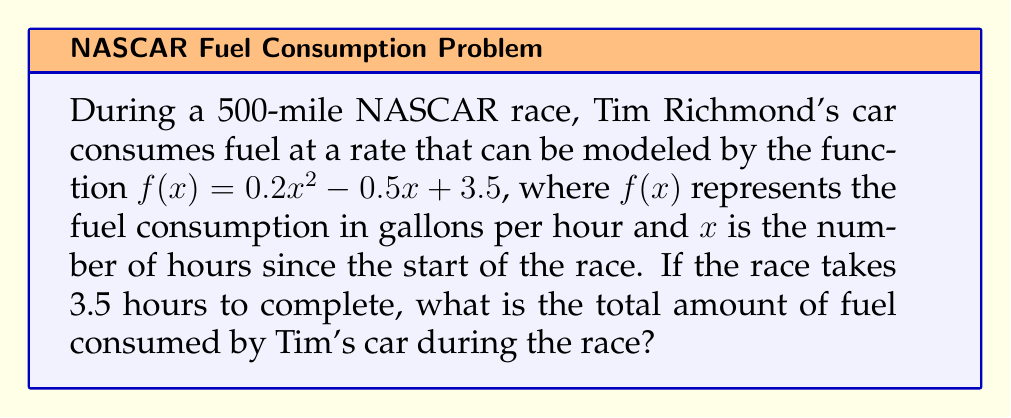Help me with this question. To solve this problem, we need to find the integral of the fuel consumption rate function over the duration of the race. Here's how we do it step-by-step:

1) The fuel consumption rate is given by $f(x) = 0.2x^2 - 0.5x + 3.5$ gallons per hour.

2) To find the total fuel consumed, we need to integrate this function from $x=0$ to $x=3.5$ (the duration of the race):

   $$\int_0^{3.5} (0.2x^2 - 0.5x + 3.5) dx$$

3) Let's integrate each term:
   
   $$\left[\frac{0.2x^3}{3} - \frac{0.5x^2}{2} + 3.5x\right]_0^{3.5}$$

4) Now, let's evaluate this at the upper and lower bounds:

   At $x=3.5$: 
   $$\frac{0.2(3.5)^3}{3} - \frac{0.5(3.5)^2}{2} + 3.5(3.5) = 8.575 - 3.0625 + 12.25 = 17.7625$$

   At $x=0$: 
   $$\frac{0.2(0)^3}{3} - \frac{0.5(0)^2}{2} + 3.5(0) = 0$$

5) The difference gives us the total fuel consumed:

   $$17.7625 - 0 = 17.7625$$ gallons

Therefore, Tim Richmond's car consumes approximately 17.76 gallons of fuel during the race.
Answer: 17.76 gallons 